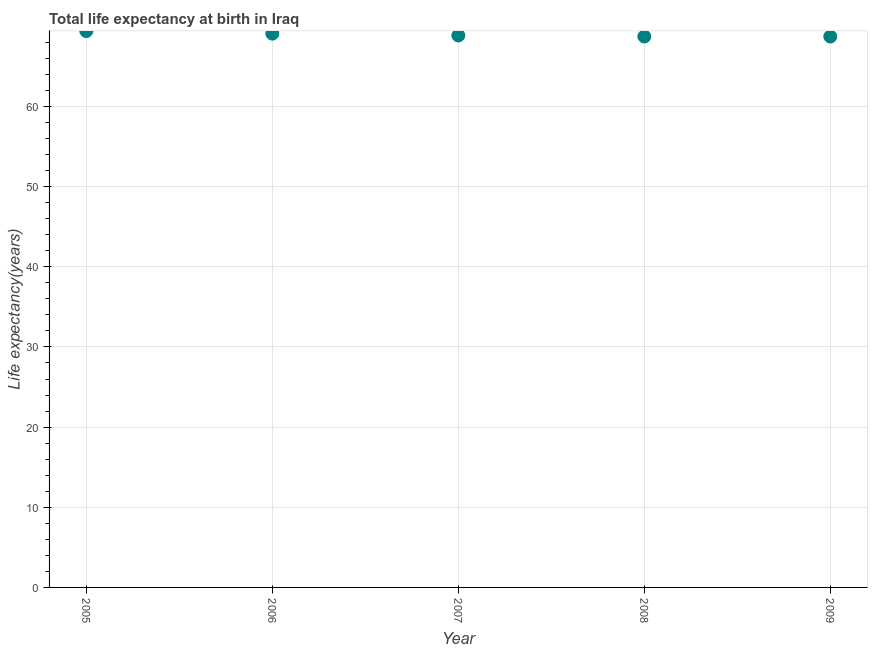What is the life expectancy at birth in 2008?
Provide a succinct answer. 68.73. Across all years, what is the maximum life expectancy at birth?
Your answer should be compact. 69.41. Across all years, what is the minimum life expectancy at birth?
Offer a very short reply. 68.73. What is the sum of the life expectancy at birth?
Your answer should be compact. 344.82. What is the difference between the life expectancy at birth in 2007 and 2009?
Offer a very short reply. 0.13. What is the average life expectancy at birth per year?
Ensure brevity in your answer.  68.96. What is the median life expectancy at birth?
Make the answer very short. 68.86. Do a majority of the years between 2005 and 2007 (inclusive) have life expectancy at birth greater than 58 years?
Provide a succinct answer. Yes. What is the ratio of the life expectancy at birth in 2006 to that in 2008?
Offer a terse response. 1.01. Is the difference between the life expectancy at birth in 2008 and 2009 greater than the difference between any two years?
Give a very brief answer. No. What is the difference between the highest and the second highest life expectancy at birth?
Keep it short and to the point. 0.32. Is the sum of the life expectancy at birth in 2006 and 2009 greater than the maximum life expectancy at birth across all years?
Offer a terse response. Yes. What is the difference between the highest and the lowest life expectancy at birth?
Give a very brief answer. 0.68. In how many years, is the life expectancy at birth greater than the average life expectancy at birth taken over all years?
Your answer should be compact. 2. Does the graph contain any zero values?
Ensure brevity in your answer.  No. What is the title of the graph?
Your response must be concise. Total life expectancy at birth in Iraq. What is the label or title of the X-axis?
Provide a short and direct response. Year. What is the label or title of the Y-axis?
Offer a very short reply. Life expectancy(years). What is the Life expectancy(years) in 2005?
Give a very brief answer. 69.41. What is the Life expectancy(years) in 2006?
Ensure brevity in your answer.  69.09. What is the Life expectancy(years) in 2007?
Your response must be concise. 68.86. What is the Life expectancy(years) in 2008?
Give a very brief answer. 68.73. What is the Life expectancy(years) in 2009?
Offer a terse response. 68.73. What is the difference between the Life expectancy(years) in 2005 and 2006?
Make the answer very short. 0.32. What is the difference between the Life expectancy(years) in 2005 and 2007?
Your response must be concise. 0.55. What is the difference between the Life expectancy(years) in 2005 and 2008?
Provide a succinct answer. 0.67. What is the difference between the Life expectancy(years) in 2005 and 2009?
Your answer should be very brief. 0.68. What is the difference between the Life expectancy(years) in 2006 and 2007?
Your answer should be compact. 0.23. What is the difference between the Life expectancy(years) in 2006 and 2008?
Give a very brief answer. 0.36. What is the difference between the Life expectancy(years) in 2006 and 2009?
Your answer should be compact. 0.36. What is the difference between the Life expectancy(years) in 2007 and 2008?
Provide a short and direct response. 0.12. What is the difference between the Life expectancy(years) in 2007 and 2009?
Your answer should be compact. 0.13. What is the difference between the Life expectancy(years) in 2008 and 2009?
Keep it short and to the point. 0.01. What is the ratio of the Life expectancy(years) in 2005 to that in 2008?
Give a very brief answer. 1.01. What is the ratio of the Life expectancy(years) in 2006 to that in 2008?
Give a very brief answer. 1. What is the ratio of the Life expectancy(years) in 2006 to that in 2009?
Your response must be concise. 1. What is the ratio of the Life expectancy(years) in 2008 to that in 2009?
Your response must be concise. 1. 